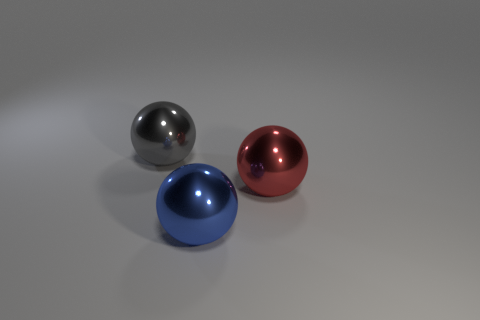Add 3 gray objects. How many objects exist? 6 Subtract all yellow balls. Subtract all green cylinders. How many balls are left? 3 Add 1 large green rubber blocks. How many large green rubber blocks exist? 1 Subtract 0 gray cylinders. How many objects are left? 3 Subtract all metallic objects. Subtract all large yellow shiny cylinders. How many objects are left? 0 Add 1 large red shiny spheres. How many large red shiny spheres are left? 2 